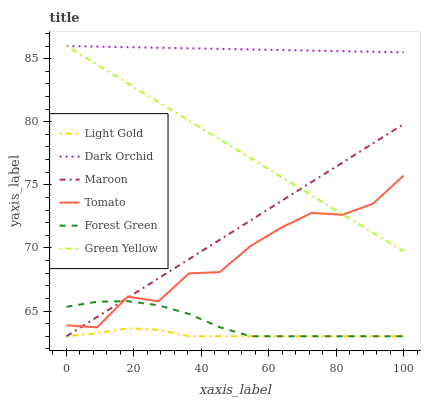Does Light Gold have the minimum area under the curve?
Answer yes or no. Yes. Does Dark Orchid have the maximum area under the curve?
Answer yes or no. Yes. Does Maroon have the minimum area under the curve?
Answer yes or no. No. Does Maroon have the maximum area under the curve?
Answer yes or no. No. Is Green Yellow the smoothest?
Answer yes or no. Yes. Is Tomato the roughest?
Answer yes or no. Yes. Is Maroon the smoothest?
Answer yes or no. No. Is Maroon the roughest?
Answer yes or no. No. Does Dark Orchid have the lowest value?
Answer yes or no. No. Does Maroon have the highest value?
Answer yes or no. No. Is Tomato less than Dark Orchid?
Answer yes or no. Yes. Is Dark Orchid greater than Forest Green?
Answer yes or no. Yes. Does Tomato intersect Dark Orchid?
Answer yes or no. No. 